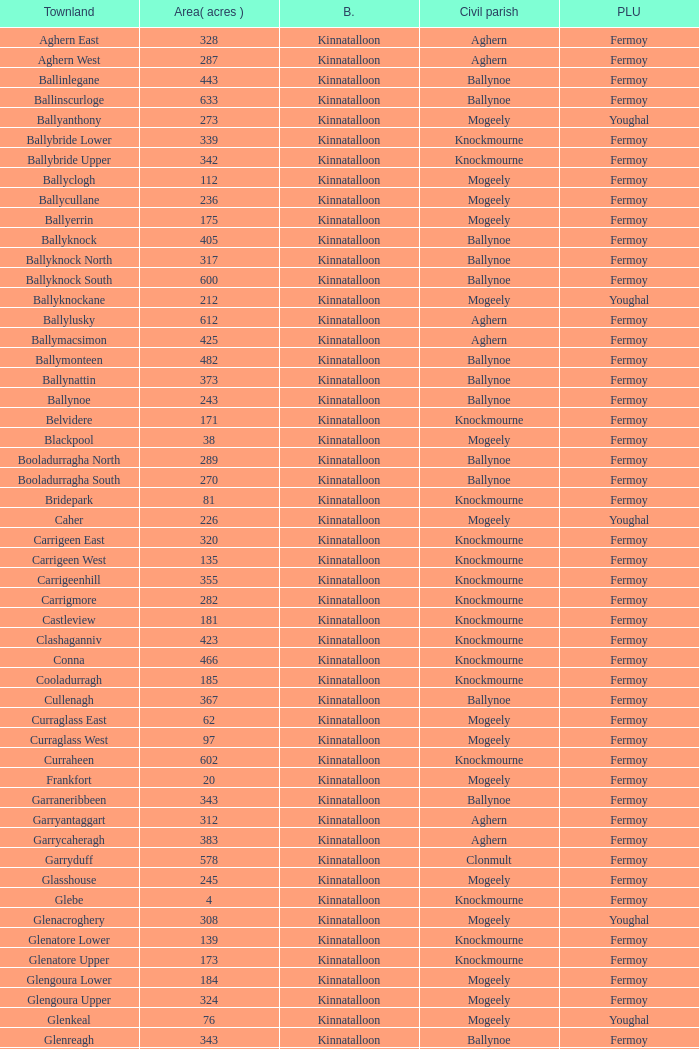Would you be able to parse every entry in this table? {'header': ['Townland', 'Area( acres )', 'B.', 'Civil parish', 'PLU'], 'rows': [['Aghern East', '328', 'Kinnatalloon', 'Aghern', 'Fermoy'], ['Aghern West', '287', 'Kinnatalloon', 'Aghern', 'Fermoy'], ['Ballinlegane', '443', 'Kinnatalloon', 'Ballynoe', 'Fermoy'], ['Ballinscurloge', '633', 'Kinnatalloon', 'Ballynoe', 'Fermoy'], ['Ballyanthony', '273', 'Kinnatalloon', 'Mogeely', 'Youghal'], ['Ballybride Lower', '339', 'Kinnatalloon', 'Knockmourne', 'Fermoy'], ['Ballybride Upper', '342', 'Kinnatalloon', 'Knockmourne', 'Fermoy'], ['Ballyclogh', '112', 'Kinnatalloon', 'Mogeely', 'Fermoy'], ['Ballycullane', '236', 'Kinnatalloon', 'Mogeely', 'Fermoy'], ['Ballyerrin', '175', 'Kinnatalloon', 'Mogeely', 'Fermoy'], ['Ballyknock', '405', 'Kinnatalloon', 'Ballynoe', 'Fermoy'], ['Ballyknock North', '317', 'Kinnatalloon', 'Ballynoe', 'Fermoy'], ['Ballyknock South', '600', 'Kinnatalloon', 'Ballynoe', 'Fermoy'], ['Ballyknockane', '212', 'Kinnatalloon', 'Mogeely', 'Youghal'], ['Ballylusky', '612', 'Kinnatalloon', 'Aghern', 'Fermoy'], ['Ballymacsimon', '425', 'Kinnatalloon', 'Aghern', 'Fermoy'], ['Ballymonteen', '482', 'Kinnatalloon', 'Ballynoe', 'Fermoy'], ['Ballynattin', '373', 'Kinnatalloon', 'Ballynoe', 'Fermoy'], ['Ballynoe', '243', 'Kinnatalloon', 'Ballynoe', 'Fermoy'], ['Belvidere', '171', 'Kinnatalloon', 'Knockmourne', 'Fermoy'], ['Blackpool', '38', 'Kinnatalloon', 'Mogeely', 'Fermoy'], ['Booladurragha North', '289', 'Kinnatalloon', 'Ballynoe', 'Fermoy'], ['Booladurragha South', '270', 'Kinnatalloon', 'Ballynoe', 'Fermoy'], ['Bridepark', '81', 'Kinnatalloon', 'Knockmourne', 'Fermoy'], ['Caher', '226', 'Kinnatalloon', 'Mogeely', 'Youghal'], ['Carrigeen East', '320', 'Kinnatalloon', 'Knockmourne', 'Fermoy'], ['Carrigeen West', '135', 'Kinnatalloon', 'Knockmourne', 'Fermoy'], ['Carrigeenhill', '355', 'Kinnatalloon', 'Knockmourne', 'Fermoy'], ['Carrigmore', '282', 'Kinnatalloon', 'Knockmourne', 'Fermoy'], ['Castleview', '181', 'Kinnatalloon', 'Knockmourne', 'Fermoy'], ['Clashaganniv', '423', 'Kinnatalloon', 'Knockmourne', 'Fermoy'], ['Conna', '466', 'Kinnatalloon', 'Knockmourne', 'Fermoy'], ['Cooladurragh', '185', 'Kinnatalloon', 'Knockmourne', 'Fermoy'], ['Cullenagh', '367', 'Kinnatalloon', 'Ballynoe', 'Fermoy'], ['Curraglass East', '62', 'Kinnatalloon', 'Mogeely', 'Fermoy'], ['Curraglass West', '97', 'Kinnatalloon', 'Mogeely', 'Fermoy'], ['Curraheen', '602', 'Kinnatalloon', 'Knockmourne', 'Fermoy'], ['Frankfort', '20', 'Kinnatalloon', 'Mogeely', 'Fermoy'], ['Garraneribbeen', '343', 'Kinnatalloon', 'Ballynoe', 'Fermoy'], ['Garryantaggart', '312', 'Kinnatalloon', 'Aghern', 'Fermoy'], ['Garrycaheragh', '383', 'Kinnatalloon', 'Aghern', 'Fermoy'], ['Garryduff', '578', 'Kinnatalloon', 'Clonmult', 'Fermoy'], ['Glasshouse', '245', 'Kinnatalloon', 'Mogeely', 'Fermoy'], ['Glebe', '4', 'Kinnatalloon', 'Knockmourne', 'Fermoy'], ['Glenacroghery', '308', 'Kinnatalloon', 'Mogeely', 'Youghal'], ['Glenatore Lower', '139', 'Kinnatalloon', 'Knockmourne', 'Fermoy'], ['Glenatore Upper', '173', 'Kinnatalloon', 'Knockmourne', 'Fermoy'], ['Glengoura Lower', '184', 'Kinnatalloon', 'Mogeely', 'Fermoy'], ['Glengoura Upper', '324', 'Kinnatalloon', 'Mogeely', 'Fermoy'], ['Glenkeal', '76', 'Kinnatalloon', 'Mogeely', 'Youghal'], ['Glenreagh', '343', 'Kinnatalloon', 'Ballynoe', 'Fermoy'], ['Glentane', '274', 'Kinnatalloon', 'Ballynoe', 'Fermoy'], ['Glentrasna', '284', 'Kinnatalloon', 'Aghern', 'Fermoy'], ['Glentrasna North', '219', 'Kinnatalloon', 'Aghern', 'Fermoy'], ['Glentrasna South', '220', 'Kinnatalloon', 'Aghern', 'Fermoy'], ['Gortnafira', '78', 'Kinnatalloon', 'Mogeely', 'Fermoy'], ['Inchyallagh', '8', 'Kinnatalloon', 'Mogeely', 'Fermoy'], ['Kilclare Lower', '109', 'Kinnatalloon', 'Knockmourne', 'Fermoy'], ['Kilclare Upper', '493', 'Kinnatalloon', 'Knockmourne', 'Fermoy'], ['Kilcronat', '516', 'Kinnatalloon', 'Mogeely', 'Youghal'], ['Kilcronatmountain', '385', 'Kinnatalloon', 'Mogeely', 'Youghal'], ['Killasseragh', '340', 'Kinnatalloon', 'Ballynoe', 'Fermoy'], ['Killavarilly', '372', 'Kinnatalloon', 'Knockmourne', 'Fermoy'], ['Kilmacow', '316', 'Kinnatalloon', 'Mogeely', 'Fermoy'], ['Kilnafurrery', '256', 'Kinnatalloon', 'Mogeely', 'Youghal'], ['Kilphillibeen', '535', 'Kinnatalloon', 'Ballynoe', 'Fermoy'], ['Knockacool', '404', 'Kinnatalloon', 'Mogeely', 'Youghal'], ['Knockakeo', '296', 'Kinnatalloon', 'Ballynoe', 'Fermoy'], ['Knockanarrig', '215', 'Kinnatalloon', 'Mogeely', 'Youghal'], ['Knockastickane', '164', 'Kinnatalloon', 'Knockmourne', 'Fermoy'], ['Knocknagapple', '293', 'Kinnatalloon', 'Aghern', 'Fermoy'], ['Lackbrack', '84', 'Kinnatalloon', 'Mogeely', 'Fermoy'], ['Lacken', '262', 'Kinnatalloon', 'Mogeely', 'Youghal'], ['Lackenbehy', '101', 'Kinnatalloon', 'Mogeely', 'Fermoy'], ['Limekilnclose', '41', 'Kinnatalloon', 'Mogeely', 'Lismore'], ['Lisnabrin Lower', '114', 'Kinnatalloon', 'Mogeely', 'Fermoy'], ['Lisnabrin North', '217', 'Kinnatalloon', 'Mogeely', 'Fermoy'], ['Lisnabrin South', '180', 'Kinnatalloon', 'Mogeely', 'Fermoy'], ['Lisnabrinlodge', '28', 'Kinnatalloon', 'Mogeely', 'Fermoy'], ['Littlegrace', '50', 'Kinnatalloon', 'Knockmourne', 'Lismore'], ['Longueville North', '355', 'Kinnatalloon', 'Ballynoe', 'Fermoy'], ['Longueville South', '271', 'Kinnatalloon', 'Ballynoe', 'Fermoy'], ['Lyre', '160', 'Kinnatalloon', 'Mogeely', 'Youghal'], ['Lyre Mountain', '360', 'Kinnatalloon', 'Mogeely', 'Youghal'], ['Mogeely Lower', '304', 'Kinnatalloon', 'Mogeely', 'Fermoy'], ['Mogeely Upper', '247', 'Kinnatalloon', 'Mogeely', 'Fermoy'], ['Monagown', '491', 'Kinnatalloon', 'Knockmourne', 'Fermoy'], ['Monaloo', '458', 'Kinnatalloon', 'Mogeely', 'Youghal'], ['Mountprospect', '102', 'Kinnatalloon', 'Mogeely', 'Fermoy'], ['Park', '119', 'Kinnatalloon', 'Aghern', 'Fermoy'], ['Poundfields', '15', 'Kinnatalloon', 'Mogeely', 'Fermoy'], ['Rathdrum', '336', 'Kinnatalloon', 'Ballynoe', 'Fermoy'], ['Rathdrum', '339', 'Kinnatalloon', 'Britway', 'Fermoy'], ['Reanduff', '318', 'Kinnatalloon', 'Mogeely', 'Youghal'], ['Rearour North', '208', 'Kinnatalloon', 'Mogeely', 'Youghal'], ['Rearour South', '223', 'Kinnatalloon', 'Mogeely', 'Youghal'], ['Rosybower', '105', 'Kinnatalloon', 'Mogeely', 'Fermoy'], ['Sandyhill', '263', 'Kinnatalloon', 'Mogeely', 'Youghal'], ['Shanaboola', '190', 'Kinnatalloon', 'Ballynoe', 'Fermoy'], ['Shanakill Lower', '244', 'Kinnatalloon', 'Mogeely', 'Fermoy'], ['Shanakill Upper', '244', 'Kinnatalloon', 'Mogeely', 'Fermoy'], ['Slieveadoctor', '260', 'Kinnatalloon', 'Mogeely', 'Fermoy'], ['Templevally', '330', 'Kinnatalloon', 'Mogeely', 'Fermoy'], ['Vinepark', '7', 'Kinnatalloon', 'Mogeely', 'Fermoy']]} Name  the townland for fermoy and ballynoe Ballinlegane, Ballinscurloge, Ballyknock, Ballyknock North, Ballyknock South, Ballymonteen, Ballynattin, Ballynoe, Booladurragha North, Booladurragha South, Cullenagh, Garraneribbeen, Glenreagh, Glentane, Killasseragh, Kilphillibeen, Knockakeo, Longueville North, Longueville South, Rathdrum, Shanaboola. 